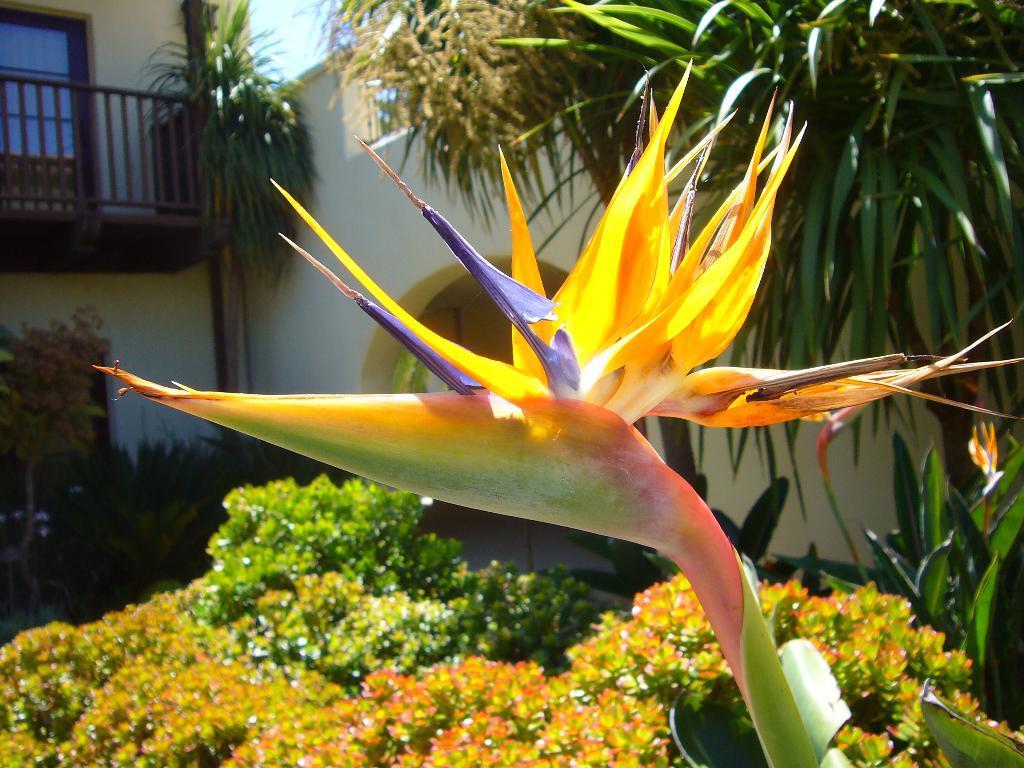In one or two sentences, can you explain what this image depicts? In this image we can see a flower. In the back there are plants. Also there is a building with railing and arch. 